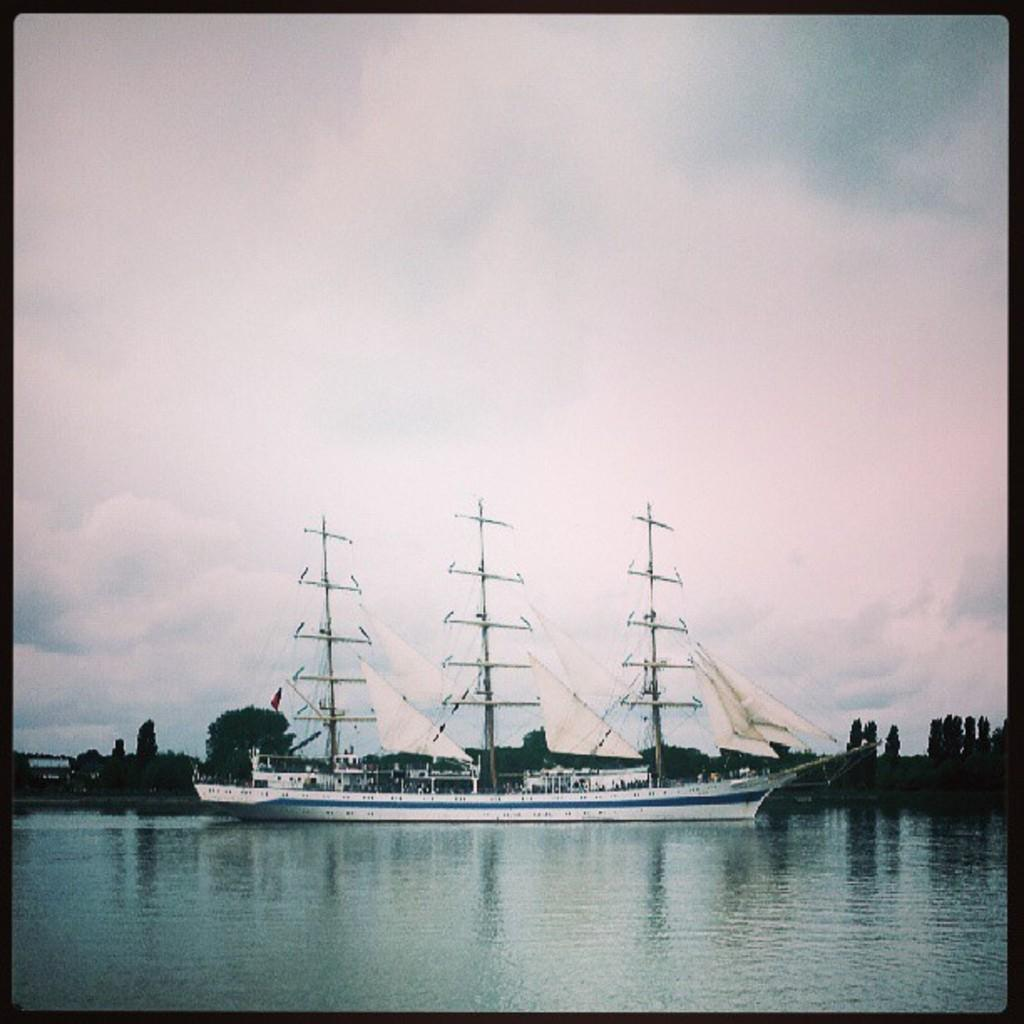What is the main subject of the image? The main subject of the image is a ship. Where is the ship located? The ship is on a river. What can be seen in the background of the image? There are trees and the sky visible in the background of the image. What is the rate at which the chess game is being played on the ship? There is no chess game present in the image, so it is not possible to determine the rate at which a game might be played. 